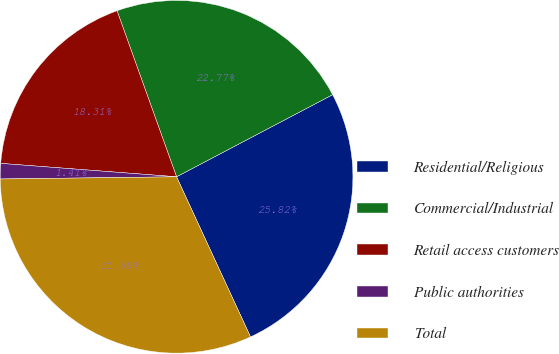Convert chart to OTSL. <chart><loc_0><loc_0><loc_500><loc_500><pie_chart><fcel>Residential/Religious<fcel>Commercial/Industrial<fcel>Retail access customers<fcel>Public authorities<fcel>Total<nl><fcel>25.82%<fcel>22.77%<fcel>18.31%<fcel>1.41%<fcel>31.69%<nl></chart> 